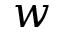Convert formula to latex. <formula><loc_0><loc_0><loc_500><loc_500>w</formula> 